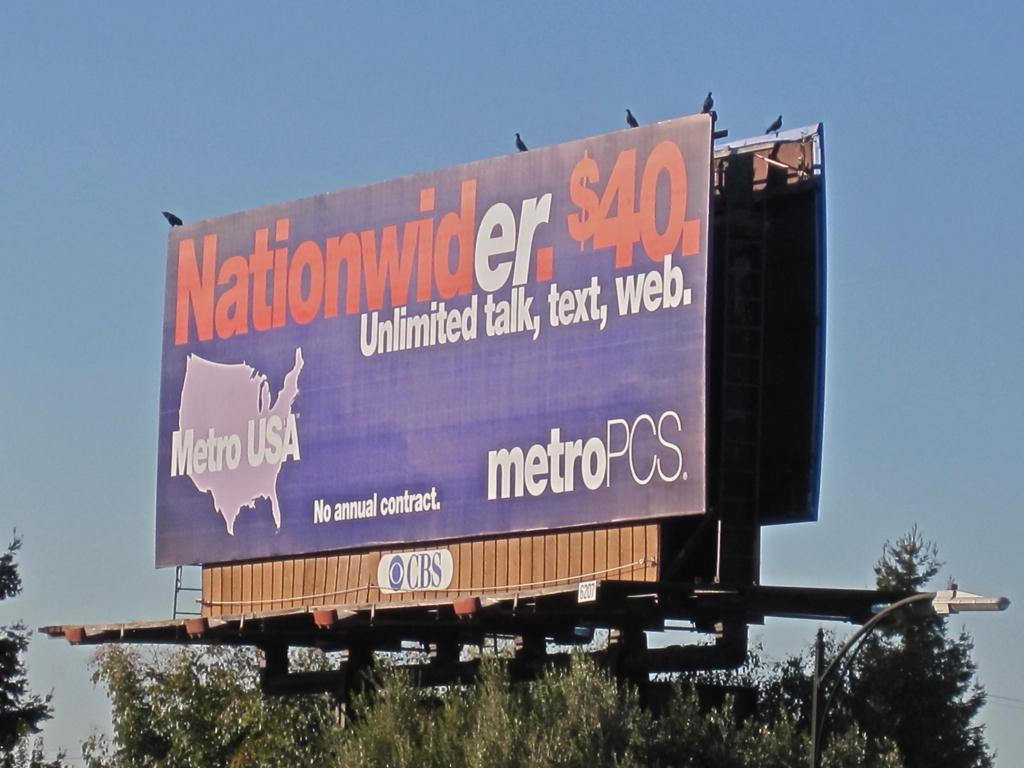<image>
Render a clear and concise summary of the photo. MetroPCS offers a natiowider plan for $40 a month 